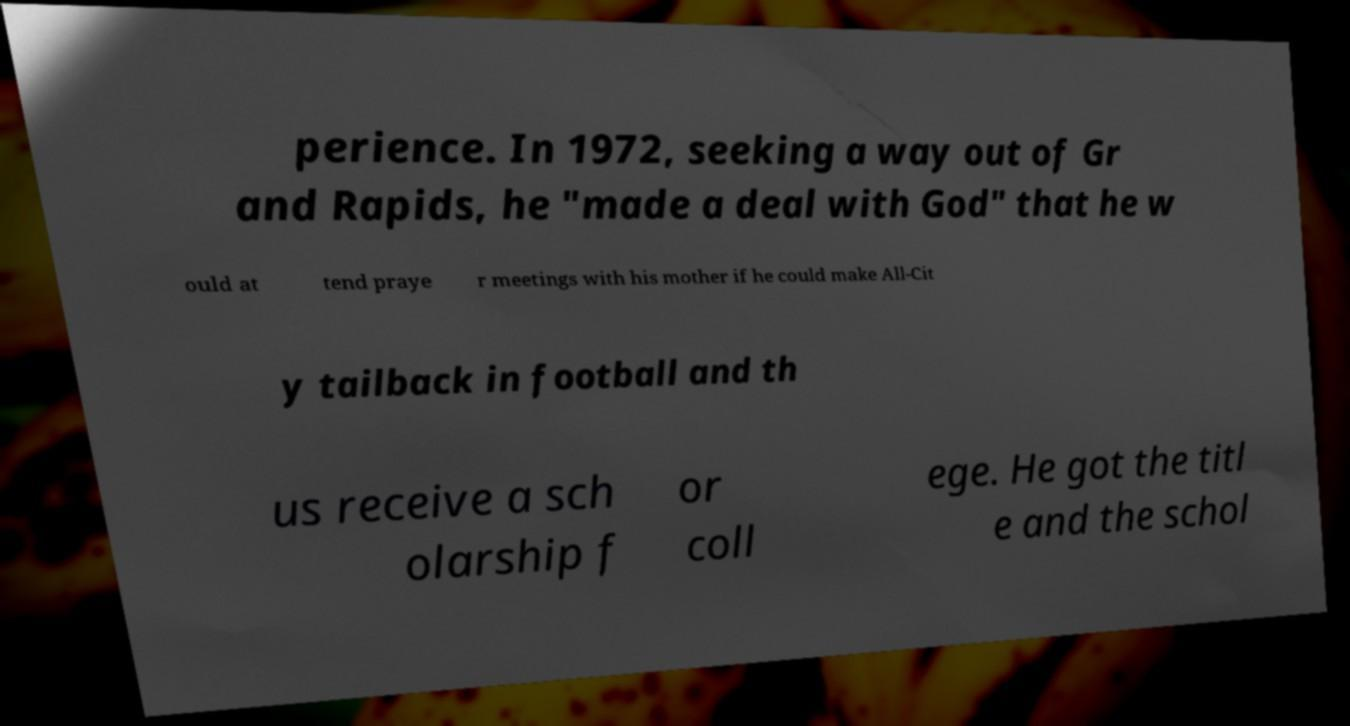What messages or text are displayed in this image? I need them in a readable, typed format. perience. In 1972, seeking a way out of Gr and Rapids, he "made a deal with God" that he w ould at tend praye r meetings with his mother if he could make All-Cit y tailback in football and th us receive a sch olarship f or coll ege. He got the titl e and the schol 